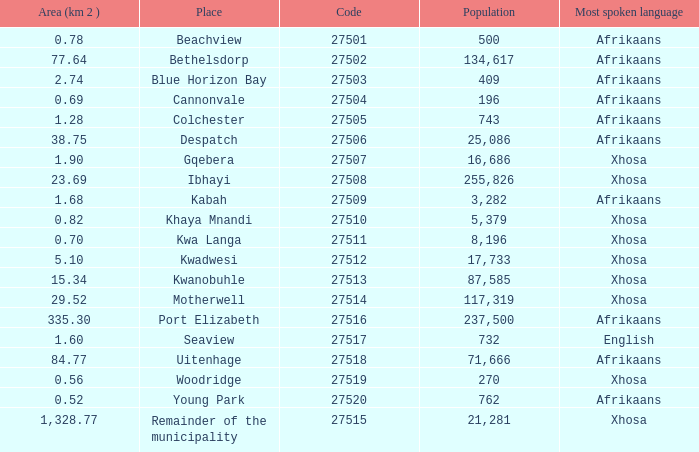What is the lowest code number for the remainder of the municipality that has an area bigger than 15.34 squared kilometers, a population greater than 762 and a language of xhosa spoken? 27515.0. 